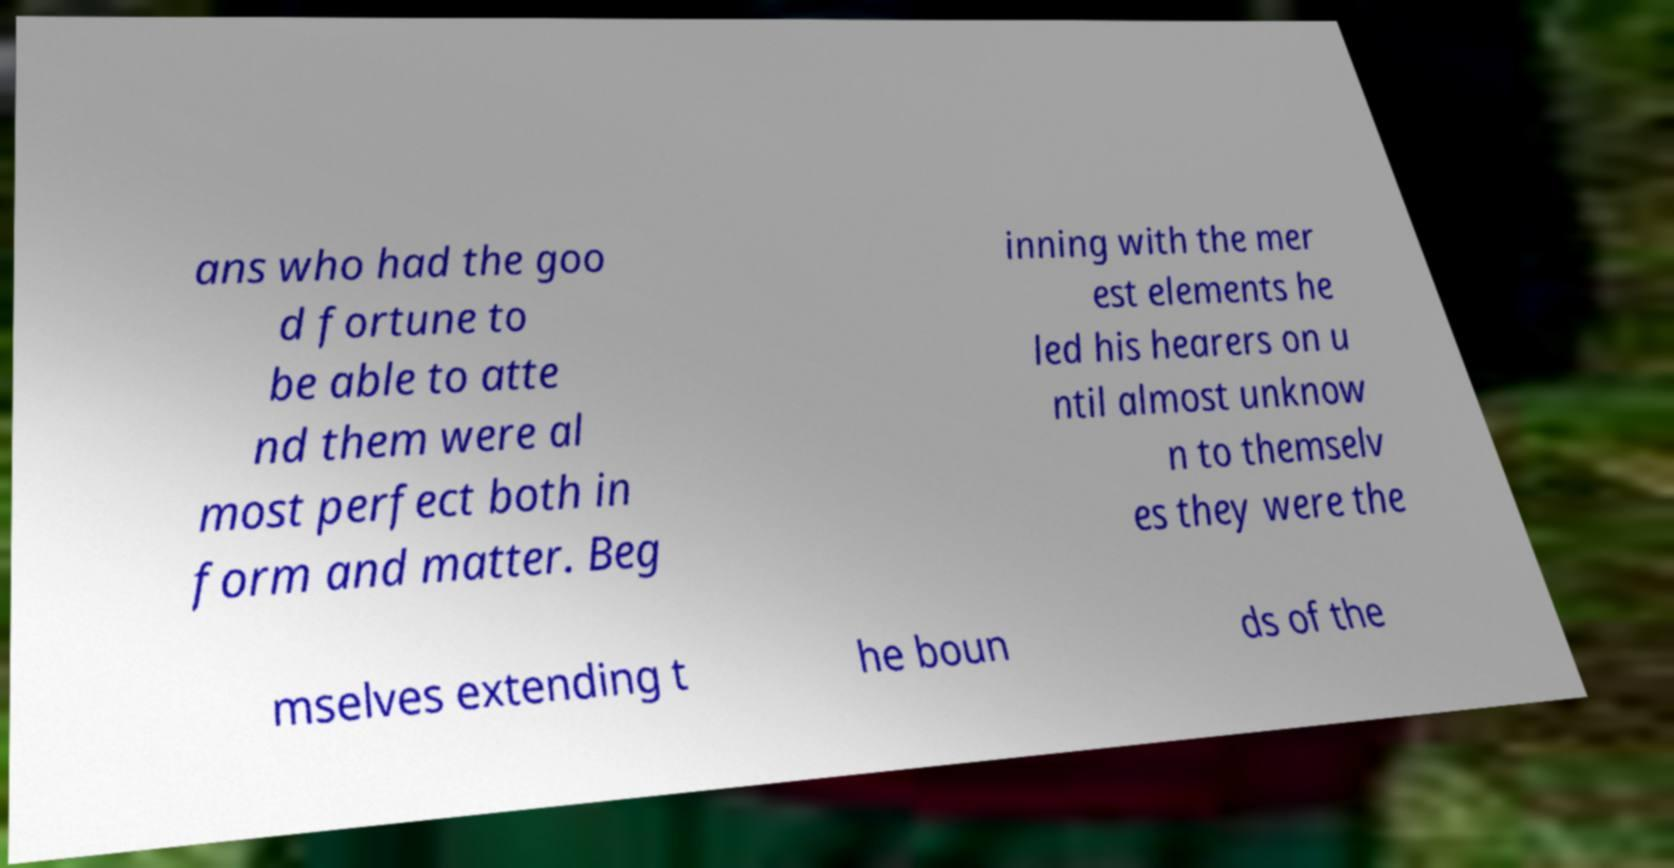There's text embedded in this image that I need extracted. Can you transcribe it verbatim? ans who had the goo d fortune to be able to atte nd them were al most perfect both in form and matter. Beg inning with the mer est elements he led his hearers on u ntil almost unknow n to themselv es they were the mselves extending t he boun ds of the 